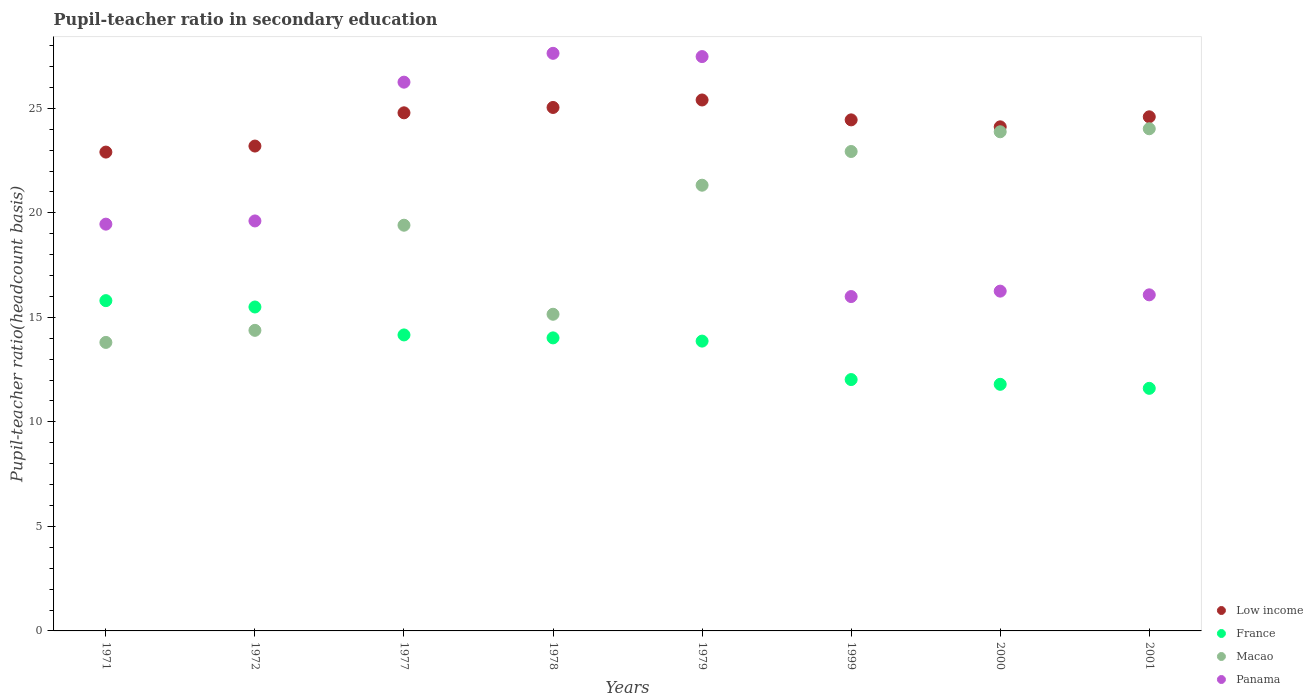How many different coloured dotlines are there?
Offer a terse response. 4. What is the pupil-teacher ratio in secondary education in France in 2001?
Your answer should be very brief. 11.61. Across all years, what is the maximum pupil-teacher ratio in secondary education in Macao?
Offer a terse response. 24.02. Across all years, what is the minimum pupil-teacher ratio in secondary education in Panama?
Your answer should be compact. 16. In which year was the pupil-teacher ratio in secondary education in Low income maximum?
Provide a succinct answer. 1979. What is the total pupil-teacher ratio in secondary education in Macao in the graph?
Keep it short and to the point. 154.91. What is the difference between the pupil-teacher ratio in secondary education in France in 1978 and that in 1999?
Give a very brief answer. 1.99. What is the difference between the pupil-teacher ratio in secondary education in Panama in 2001 and the pupil-teacher ratio in secondary education in Low income in 2000?
Your answer should be very brief. -8.04. What is the average pupil-teacher ratio in secondary education in Panama per year?
Your answer should be very brief. 21.1. In the year 1979, what is the difference between the pupil-teacher ratio in secondary education in Panama and pupil-teacher ratio in secondary education in France?
Your answer should be very brief. 13.61. What is the ratio of the pupil-teacher ratio in secondary education in France in 1979 to that in 2000?
Your answer should be very brief. 1.18. What is the difference between the highest and the second highest pupil-teacher ratio in secondary education in Macao?
Your answer should be very brief. 0.14. What is the difference between the highest and the lowest pupil-teacher ratio in secondary education in Panama?
Provide a succinct answer. 11.64. In how many years, is the pupil-teacher ratio in secondary education in France greater than the average pupil-teacher ratio in secondary education in France taken over all years?
Provide a succinct answer. 5. Is the sum of the pupil-teacher ratio in secondary education in Panama in 1999 and 2000 greater than the maximum pupil-teacher ratio in secondary education in France across all years?
Your response must be concise. Yes. Is the pupil-teacher ratio in secondary education in Macao strictly greater than the pupil-teacher ratio in secondary education in France over the years?
Your response must be concise. No. How many dotlines are there?
Your response must be concise. 4. How many years are there in the graph?
Offer a very short reply. 8. Does the graph contain any zero values?
Give a very brief answer. No. Where does the legend appear in the graph?
Provide a short and direct response. Bottom right. What is the title of the graph?
Your response must be concise. Pupil-teacher ratio in secondary education. Does "Turkey" appear as one of the legend labels in the graph?
Offer a terse response. No. What is the label or title of the X-axis?
Offer a terse response. Years. What is the label or title of the Y-axis?
Ensure brevity in your answer.  Pupil-teacher ratio(headcount basis). What is the Pupil-teacher ratio(headcount basis) of Low income in 1971?
Your answer should be very brief. 22.91. What is the Pupil-teacher ratio(headcount basis) in France in 1971?
Offer a terse response. 15.8. What is the Pupil-teacher ratio(headcount basis) in Macao in 1971?
Your response must be concise. 13.8. What is the Pupil-teacher ratio(headcount basis) of Panama in 1971?
Ensure brevity in your answer.  19.46. What is the Pupil-teacher ratio(headcount basis) of Low income in 1972?
Your answer should be compact. 23.2. What is the Pupil-teacher ratio(headcount basis) in France in 1972?
Make the answer very short. 15.5. What is the Pupil-teacher ratio(headcount basis) of Macao in 1972?
Your response must be concise. 14.38. What is the Pupil-teacher ratio(headcount basis) of Panama in 1972?
Offer a terse response. 19.61. What is the Pupil-teacher ratio(headcount basis) in Low income in 1977?
Your response must be concise. 24.79. What is the Pupil-teacher ratio(headcount basis) of France in 1977?
Your answer should be compact. 14.16. What is the Pupil-teacher ratio(headcount basis) in Macao in 1977?
Your response must be concise. 19.41. What is the Pupil-teacher ratio(headcount basis) of Panama in 1977?
Ensure brevity in your answer.  26.25. What is the Pupil-teacher ratio(headcount basis) of Low income in 1978?
Offer a terse response. 25.04. What is the Pupil-teacher ratio(headcount basis) in France in 1978?
Your response must be concise. 14.02. What is the Pupil-teacher ratio(headcount basis) in Macao in 1978?
Keep it short and to the point. 15.15. What is the Pupil-teacher ratio(headcount basis) of Panama in 1978?
Offer a terse response. 27.63. What is the Pupil-teacher ratio(headcount basis) in Low income in 1979?
Your answer should be compact. 25.4. What is the Pupil-teacher ratio(headcount basis) of France in 1979?
Provide a succinct answer. 13.87. What is the Pupil-teacher ratio(headcount basis) of Macao in 1979?
Your answer should be very brief. 21.32. What is the Pupil-teacher ratio(headcount basis) of Panama in 1979?
Ensure brevity in your answer.  27.48. What is the Pupil-teacher ratio(headcount basis) of Low income in 1999?
Your response must be concise. 24.45. What is the Pupil-teacher ratio(headcount basis) of France in 1999?
Make the answer very short. 12.03. What is the Pupil-teacher ratio(headcount basis) of Macao in 1999?
Offer a very short reply. 22.94. What is the Pupil-teacher ratio(headcount basis) in Panama in 1999?
Your response must be concise. 16. What is the Pupil-teacher ratio(headcount basis) of Low income in 2000?
Your response must be concise. 24.12. What is the Pupil-teacher ratio(headcount basis) of France in 2000?
Your answer should be compact. 11.8. What is the Pupil-teacher ratio(headcount basis) in Macao in 2000?
Make the answer very short. 23.88. What is the Pupil-teacher ratio(headcount basis) in Panama in 2000?
Provide a short and direct response. 16.26. What is the Pupil-teacher ratio(headcount basis) in Low income in 2001?
Ensure brevity in your answer.  24.6. What is the Pupil-teacher ratio(headcount basis) of France in 2001?
Offer a very short reply. 11.61. What is the Pupil-teacher ratio(headcount basis) of Macao in 2001?
Provide a succinct answer. 24.02. What is the Pupil-teacher ratio(headcount basis) of Panama in 2001?
Give a very brief answer. 16.08. Across all years, what is the maximum Pupil-teacher ratio(headcount basis) in Low income?
Offer a very short reply. 25.4. Across all years, what is the maximum Pupil-teacher ratio(headcount basis) of France?
Offer a very short reply. 15.8. Across all years, what is the maximum Pupil-teacher ratio(headcount basis) of Macao?
Keep it short and to the point. 24.02. Across all years, what is the maximum Pupil-teacher ratio(headcount basis) of Panama?
Provide a succinct answer. 27.63. Across all years, what is the minimum Pupil-teacher ratio(headcount basis) of Low income?
Give a very brief answer. 22.91. Across all years, what is the minimum Pupil-teacher ratio(headcount basis) of France?
Give a very brief answer. 11.61. Across all years, what is the minimum Pupil-teacher ratio(headcount basis) of Macao?
Make the answer very short. 13.8. Across all years, what is the minimum Pupil-teacher ratio(headcount basis) of Panama?
Provide a short and direct response. 16. What is the total Pupil-teacher ratio(headcount basis) of Low income in the graph?
Give a very brief answer. 194.5. What is the total Pupil-teacher ratio(headcount basis) of France in the graph?
Give a very brief answer. 108.77. What is the total Pupil-teacher ratio(headcount basis) in Macao in the graph?
Provide a succinct answer. 154.91. What is the total Pupil-teacher ratio(headcount basis) in Panama in the graph?
Provide a short and direct response. 168.77. What is the difference between the Pupil-teacher ratio(headcount basis) in Low income in 1971 and that in 1972?
Offer a very short reply. -0.29. What is the difference between the Pupil-teacher ratio(headcount basis) in France in 1971 and that in 1972?
Make the answer very short. 0.3. What is the difference between the Pupil-teacher ratio(headcount basis) in Macao in 1971 and that in 1972?
Give a very brief answer. -0.58. What is the difference between the Pupil-teacher ratio(headcount basis) of Panama in 1971 and that in 1972?
Give a very brief answer. -0.15. What is the difference between the Pupil-teacher ratio(headcount basis) in Low income in 1971 and that in 1977?
Give a very brief answer. -1.88. What is the difference between the Pupil-teacher ratio(headcount basis) of France in 1971 and that in 1977?
Provide a succinct answer. 1.64. What is the difference between the Pupil-teacher ratio(headcount basis) of Macao in 1971 and that in 1977?
Offer a terse response. -5.61. What is the difference between the Pupil-teacher ratio(headcount basis) of Panama in 1971 and that in 1977?
Keep it short and to the point. -6.79. What is the difference between the Pupil-teacher ratio(headcount basis) in Low income in 1971 and that in 1978?
Your answer should be compact. -2.13. What is the difference between the Pupil-teacher ratio(headcount basis) of France in 1971 and that in 1978?
Your answer should be very brief. 1.78. What is the difference between the Pupil-teacher ratio(headcount basis) in Macao in 1971 and that in 1978?
Give a very brief answer. -1.35. What is the difference between the Pupil-teacher ratio(headcount basis) of Panama in 1971 and that in 1978?
Ensure brevity in your answer.  -8.17. What is the difference between the Pupil-teacher ratio(headcount basis) in Low income in 1971 and that in 1979?
Your response must be concise. -2.49. What is the difference between the Pupil-teacher ratio(headcount basis) in France in 1971 and that in 1979?
Keep it short and to the point. 1.94. What is the difference between the Pupil-teacher ratio(headcount basis) in Macao in 1971 and that in 1979?
Your answer should be very brief. -7.52. What is the difference between the Pupil-teacher ratio(headcount basis) in Panama in 1971 and that in 1979?
Offer a terse response. -8.02. What is the difference between the Pupil-teacher ratio(headcount basis) in Low income in 1971 and that in 1999?
Offer a terse response. -1.54. What is the difference between the Pupil-teacher ratio(headcount basis) in France in 1971 and that in 1999?
Give a very brief answer. 3.78. What is the difference between the Pupil-teacher ratio(headcount basis) of Macao in 1971 and that in 1999?
Your answer should be compact. -9.13. What is the difference between the Pupil-teacher ratio(headcount basis) of Panama in 1971 and that in 1999?
Ensure brevity in your answer.  3.46. What is the difference between the Pupil-teacher ratio(headcount basis) of Low income in 1971 and that in 2000?
Your answer should be very brief. -1.21. What is the difference between the Pupil-teacher ratio(headcount basis) in France in 1971 and that in 2000?
Your response must be concise. 4. What is the difference between the Pupil-teacher ratio(headcount basis) of Macao in 1971 and that in 2000?
Ensure brevity in your answer.  -10.08. What is the difference between the Pupil-teacher ratio(headcount basis) of Panama in 1971 and that in 2000?
Ensure brevity in your answer.  3.2. What is the difference between the Pupil-teacher ratio(headcount basis) of Low income in 1971 and that in 2001?
Provide a short and direct response. -1.69. What is the difference between the Pupil-teacher ratio(headcount basis) of France in 1971 and that in 2001?
Offer a very short reply. 4.2. What is the difference between the Pupil-teacher ratio(headcount basis) in Macao in 1971 and that in 2001?
Make the answer very short. -10.22. What is the difference between the Pupil-teacher ratio(headcount basis) of Panama in 1971 and that in 2001?
Offer a terse response. 3.38. What is the difference between the Pupil-teacher ratio(headcount basis) of Low income in 1972 and that in 1977?
Give a very brief answer. -1.59. What is the difference between the Pupil-teacher ratio(headcount basis) of France in 1972 and that in 1977?
Offer a very short reply. 1.34. What is the difference between the Pupil-teacher ratio(headcount basis) of Macao in 1972 and that in 1977?
Make the answer very short. -5.03. What is the difference between the Pupil-teacher ratio(headcount basis) in Panama in 1972 and that in 1977?
Offer a terse response. -6.64. What is the difference between the Pupil-teacher ratio(headcount basis) of Low income in 1972 and that in 1978?
Give a very brief answer. -1.85. What is the difference between the Pupil-teacher ratio(headcount basis) in France in 1972 and that in 1978?
Make the answer very short. 1.48. What is the difference between the Pupil-teacher ratio(headcount basis) in Macao in 1972 and that in 1978?
Offer a terse response. -0.77. What is the difference between the Pupil-teacher ratio(headcount basis) of Panama in 1972 and that in 1978?
Offer a terse response. -8.02. What is the difference between the Pupil-teacher ratio(headcount basis) in Low income in 1972 and that in 1979?
Make the answer very short. -2.2. What is the difference between the Pupil-teacher ratio(headcount basis) in France in 1972 and that in 1979?
Make the answer very short. 1.63. What is the difference between the Pupil-teacher ratio(headcount basis) of Macao in 1972 and that in 1979?
Make the answer very short. -6.94. What is the difference between the Pupil-teacher ratio(headcount basis) of Panama in 1972 and that in 1979?
Your response must be concise. -7.86. What is the difference between the Pupil-teacher ratio(headcount basis) of Low income in 1972 and that in 1999?
Provide a short and direct response. -1.25. What is the difference between the Pupil-teacher ratio(headcount basis) of France in 1972 and that in 1999?
Make the answer very short. 3.47. What is the difference between the Pupil-teacher ratio(headcount basis) of Macao in 1972 and that in 1999?
Provide a succinct answer. -8.56. What is the difference between the Pupil-teacher ratio(headcount basis) in Panama in 1972 and that in 1999?
Offer a very short reply. 3.62. What is the difference between the Pupil-teacher ratio(headcount basis) in Low income in 1972 and that in 2000?
Offer a very short reply. -0.92. What is the difference between the Pupil-teacher ratio(headcount basis) of France in 1972 and that in 2000?
Ensure brevity in your answer.  3.7. What is the difference between the Pupil-teacher ratio(headcount basis) in Macao in 1972 and that in 2000?
Make the answer very short. -9.5. What is the difference between the Pupil-teacher ratio(headcount basis) in Panama in 1972 and that in 2000?
Keep it short and to the point. 3.36. What is the difference between the Pupil-teacher ratio(headcount basis) of Low income in 1972 and that in 2001?
Keep it short and to the point. -1.4. What is the difference between the Pupil-teacher ratio(headcount basis) of France in 1972 and that in 2001?
Provide a short and direct response. 3.89. What is the difference between the Pupil-teacher ratio(headcount basis) of Macao in 1972 and that in 2001?
Offer a terse response. -9.64. What is the difference between the Pupil-teacher ratio(headcount basis) in Panama in 1972 and that in 2001?
Your answer should be compact. 3.54. What is the difference between the Pupil-teacher ratio(headcount basis) of Low income in 1977 and that in 1978?
Ensure brevity in your answer.  -0.26. What is the difference between the Pupil-teacher ratio(headcount basis) in France in 1977 and that in 1978?
Your response must be concise. 0.14. What is the difference between the Pupil-teacher ratio(headcount basis) of Macao in 1977 and that in 1978?
Offer a terse response. 4.26. What is the difference between the Pupil-teacher ratio(headcount basis) in Panama in 1977 and that in 1978?
Give a very brief answer. -1.38. What is the difference between the Pupil-teacher ratio(headcount basis) in Low income in 1977 and that in 1979?
Ensure brevity in your answer.  -0.61. What is the difference between the Pupil-teacher ratio(headcount basis) of France in 1977 and that in 1979?
Your response must be concise. 0.3. What is the difference between the Pupil-teacher ratio(headcount basis) in Macao in 1977 and that in 1979?
Your answer should be compact. -1.91. What is the difference between the Pupil-teacher ratio(headcount basis) in Panama in 1977 and that in 1979?
Your answer should be very brief. -1.22. What is the difference between the Pupil-teacher ratio(headcount basis) of Low income in 1977 and that in 1999?
Keep it short and to the point. 0.34. What is the difference between the Pupil-teacher ratio(headcount basis) of France in 1977 and that in 1999?
Keep it short and to the point. 2.14. What is the difference between the Pupil-teacher ratio(headcount basis) of Macao in 1977 and that in 1999?
Your response must be concise. -3.53. What is the difference between the Pupil-teacher ratio(headcount basis) in Panama in 1977 and that in 1999?
Give a very brief answer. 10.26. What is the difference between the Pupil-teacher ratio(headcount basis) of Low income in 1977 and that in 2000?
Give a very brief answer. 0.67. What is the difference between the Pupil-teacher ratio(headcount basis) in France in 1977 and that in 2000?
Offer a terse response. 2.36. What is the difference between the Pupil-teacher ratio(headcount basis) of Macao in 1977 and that in 2000?
Give a very brief answer. -4.47. What is the difference between the Pupil-teacher ratio(headcount basis) of Panama in 1977 and that in 2000?
Offer a very short reply. 10. What is the difference between the Pupil-teacher ratio(headcount basis) of Low income in 1977 and that in 2001?
Provide a short and direct response. 0.19. What is the difference between the Pupil-teacher ratio(headcount basis) of France in 1977 and that in 2001?
Offer a very short reply. 2.56. What is the difference between the Pupil-teacher ratio(headcount basis) of Macao in 1977 and that in 2001?
Offer a terse response. -4.61. What is the difference between the Pupil-teacher ratio(headcount basis) of Panama in 1977 and that in 2001?
Make the answer very short. 10.17. What is the difference between the Pupil-teacher ratio(headcount basis) in Low income in 1978 and that in 1979?
Your answer should be very brief. -0.36. What is the difference between the Pupil-teacher ratio(headcount basis) in France in 1978 and that in 1979?
Offer a very short reply. 0.15. What is the difference between the Pupil-teacher ratio(headcount basis) in Macao in 1978 and that in 1979?
Provide a short and direct response. -6.17. What is the difference between the Pupil-teacher ratio(headcount basis) of Panama in 1978 and that in 1979?
Your response must be concise. 0.16. What is the difference between the Pupil-teacher ratio(headcount basis) of Low income in 1978 and that in 1999?
Provide a short and direct response. 0.59. What is the difference between the Pupil-teacher ratio(headcount basis) of France in 1978 and that in 1999?
Your answer should be very brief. 1.99. What is the difference between the Pupil-teacher ratio(headcount basis) in Macao in 1978 and that in 1999?
Ensure brevity in your answer.  -7.79. What is the difference between the Pupil-teacher ratio(headcount basis) in Panama in 1978 and that in 1999?
Ensure brevity in your answer.  11.64. What is the difference between the Pupil-teacher ratio(headcount basis) in Low income in 1978 and that in 2000?
Make the answer very short. 0.93. What is the difference between the Pupil-teacher ratio(headcount basis) of France in 1978 and that in 2000?
Offer a terse response. 2.22. What is the difference between the Pupil-teacher ratio(headcount basis) in Macao in 1978 and that in 2000?
Ensure brevity in your answer.  -8.73. What is the difference between the Pupil-teacher ratio(headcount basis) of Panama in 1978 and that in 2000?
Give a very brief answer. 11.38. What is the difference between the Pupil-teacher ratio(headcount basis) of Low income in 1978 and that in 2001?
Offer a terse response. 0.45. What is the difference between the Pupil-teacher ratio(headcount basis) of France in 1978 and that in 2001?
Offer a terse response. 2.41. What is the difference between the Pupil-teacher ratio(headcount basis) in Macao in 1978 and that in 2001?
Your answer should be compact. -8.87. What is the difference between the Pupil-teacher ratio(headcount basis) of Panama in 1978 and that in 2001?
Give a very brief answer. 11.55. What is the difference between the Pupil-teacher ratio(headcount basis) of Low income in 1979 and that in 1999?
Make the answer very short. 0.95. What is the difference between the Pupil-teacher ratio(headcount basis) of France in 1979 and that in 1999?
Offer a terse response. 1.84. What is the difference between the Pupil-teacher ratio(headcount basis) of Macao in 1979 and that in 1999?
Your response must be concise. -1.61. What is the difference between the Pupil-teacher ratio(headcount basis) in Panama in 1979 and that in 1999?
Your answer should be very brief. 11.48. What is the difference between the Pupil-teacher ratio(headcount basis) of Low income in 1979 and that in 2000?
Keep it short and to the point. 1.28. What is the difference between the Pupil-teacher ratio(headcount basis) in France in 1979 and that in 2000?
Offer a very short reply. 2.07. What is the difference between the Pupil-teacher ratio(headcount basis) of Macao in 1979 and that in 2000?
Provide a short and direct response. -2.56. What is the difference between the Pupil-teacher ratio(headcount basis) of Panama in 1979 and that in 2000?
Your response must be concise. 11.22. What is the difference between the Pupil-teacher ratio(headcount basis) of Low income in 1979 and that in 2001?
Offer a very short reply. 0.81. What is the difference between the Pupil-teacher ratio(headcount basis) of France in 1979 and that in 2001?
Provide a succinct answer. 2.26. What is the difference between the Pupil-teacher ratio(headcount basis) of Panama in 1979 and that in 2001?
Ensure brevity in your answer.  11.4. What is the difference between the Pupil-teacher ratio(headcount basis) of Low income in 1999 and that in 2000?
Give a very brief answer. 0.33. What is the difference between the Pupil-teacher ratio(headcount basis) in France in 1999 and that in 2000?
Your answer should be very brief. 0.23. What is the difference between the Pupil-teacher ratio(headcount basis) in Macao in 1999 and that in 2000?
Your response must be concise. -0.94. What is the difference between the Pupil-teacher ratio(headcount basis) in Panama in 1999 and that in 2000?
Offer a very short reply. -0.26. What is the difference between the Pupil-teacher ratio(headcount basis) of Low income in 1999 and that in 2001?
Offer a very short reply. -0.15. What is the difference between the Pupil-teacher ratio(headcount basis) of France in 1999 and that in 2001?
Offer a terse response. 0.42. What is the difference between the Pupil-teacher ratio(headcount basis) in Macao in 1999 and that in 2001?
Your answer should be compact. -1.09. What is the difference between the Pupil-teacher ratio(headcount basis) of Panama in 1999 and that in 2001?
Give a very brief answer. -0.08. What is the difference between the Pupil-teacher ratio(headcount basis) of Low income in 2000 and that in 2001?
Offer a very short reply. -0.48. What is the difference between the Pupil-teacher ratio(headcount basis) in France in 2000 and that in 2001?
Offer a very short reply. 0.19. What is the difference between the Pupil-teacher ratio(headcount basis) of Macao in 2000 and that in 2001?
Your answer should be compact. -0.14. What is the difference between the Pupil-teacher ratio(headcount basis) in Panama in 2000 and that in 2001?
Your answer should be very brief. 0.18. What is the difference between the Pupil-teacher ratio(headcount basis) of Low income in 1971 and the Pupil-teacher ratio(headcount basis) of France in 1972?
Ensure brevity in your answer.  7.41. What is the difference between the Pupil-teacher ratio(headcount basis) in Low income in 1971 and the Pupil-teacher ratio(headcount basis) in Macao in 1972?
Your response must be concise. 8.53. What is the difference between the Pupil-teacher ratio(headcount basis) in Low income in 1971 and the Pupil-teacher ratio(headcount basis) in Panama in 1972?
Ensure brevity in your answer.  3.29. What is the difference between the Pupil-teacher ratio(headcount basis) of France in 1971 and the Pupil-teacher ratio(headcount basis) of Macao in 1972?
Make the answer very short. 1.42. What is the difference between the Pupil-teacher ratio(headcount basis) of France in 1971 and the Pupil-teacher ratio(headcount basis) of Panama in 1972?
Offer a terse response. -3.81. What is the difference between the Pupil-teacher ratio(headcount basis) in Macao in 1971 and the Pupil-teacher ratio(headcount basis) in Panama in 1972?
Give a very brief answer. -5.81. What is the difference between the Pupil-teacher ratio(headcount basis) in Low income in 1971 and the Pupil-teacher ratio(headcount basis) in France in 1977?
Offer a very short reply. 8.75. What is the difference between the Pupil-teacher ratio(headcount basis) of Low income in 1971 and the Pupil-teacher ratio(headcount basis) of Macao in 1977?
Keep it short and to the point. 3.5. What is the difference between the Pupil-teacher ratio(headcount basis) in Low income in 1971 and the Pupil-teacher ratio(headcount basis) in Panama in 1977?
Give a very brief answer. -3.35. What is the difference between the Pupil-teacher ratio(headcount basis) in France in 1971 and the Pupil-teacher ratio(headcount basis) in Macao in 1977?
Give a very brief answer. -3.61. What is the difference between the Pupil-teacher ratio(headcount basis) in France in 1971 and the Pupil-teacher ratio(headcount basis) in Panama in 1977?
Keep it short and to the point. -10.45. What is the difference between the Pupil-teacher ratio(headcount basis) of Macao in 1971 and the Pupil-teacher ratio(headcount basis) of Panama in 1977?
Give a very brief answer. -12.45. What is the difference between the Pupil-teacher ratio(headcount basis) in Low income in 1971 and the Pupil-teacher ratio(headcount basis) in France in 1978?
Ensure brevity in your answer.  8.89. What is the difference between the Pupil-teacher ratio(headcount basis) in Low income in 1971 and the Pupil-teacher ratio(headcount basis) in Macao in 1978?
Keep it short and to the point. 7.76. What is the difference between the Pupil-teacher ratio(headcount basis) of Low income in 1971 and the Pupil-teacher ratio(headcount basis) of Panama in 1978?
Ensure brevity in your answer.  -4.72. What is the difference between the Pupil-teacher ratio(headcount basis) in France in 1971 and the Pupil-teacher ratio(headcount basis) in Macao in 1978?
Offer a very short reply. 0.65. What is the difference between the Pupil-teacher ratio(headcount basis) of France in 1971 and the Pupil-teacher ratio(headcount basis) of Panama in 1978?
Make the answer very short. -11.83. What is the difference between the Pupil-teacher ratio(headcount basis) in Macao in 1971 and the Pupil-teacher ratio(headcount basis) in Panama in 1978?
Your answer should be compact. -13.83. What is the difference between the Pupil-teacher ratio(headcount basis) of Low income in 1971 and the Pupil-teacher ratio(headcount basis) of France in 1979?
Offer a terse response. 9.04. What is the difference between the Pupil-teacher ratio(headcount basis) in Low income in 1971 and the Pupil-teacher ratio(headcount basis) in Macao in 1979?
Provide a short and direct response. 1.58. What is the difference between the Pupil-teacher ratio(headcount basis) of Low income in 1971 and the Pupil-teacher ratio(headcount basis) of Panama in 1979?
Your response must be concise. -4.57. What is the difference between the Pupil-teacher ratio(headcount basis) in France in 1971 and the Pupil-teacher ratio(headcount basis) in Macao in 1979?
Your answer should be compact. -5.52. What is the difference between the Pupil-teacher ratio(headcount basis) in France in 1971 and the Pupil-teacher ratio(headcount basis) in Panama in 1979?
Keep it short and to the point. -11.68. What is the difference between the Pupil-teacher ratio(headcount basis) of Macao in 1971 and the Pupil-teacher ratio(headcount basis) of Panama in 1979?
Offer a very short reply. -13.68. What is the difference between the Pupil-teacher ratio(headcount basis) of Low income in 1971 and the Pupil-teacher ratio(headcount basis) of France in 1999?
Your response must be concise. 10.88. What is the difference between the Pupil-teacher ratio(headcount basis) of Low income in 1971 and the Pupil-teacher ratio(headcount basis) of Macao in 1999?
Provide a succinct answer. -0.03. What is the difference between the Pupil-teacher ratio(headcount basis) in Low income in 1971 and the Pupil-teacher ratio(headcount basis) in Panama in 1999?
Make the answer very short. 6.91. What is the difference between the Pupil-teacher ratio(headcount basis) of France in 1971 and the Pupil-teacher ratio(headcount basis) of Macao in 1999?
Your answer should be compact. -7.13. What is the difference between the Pupil-teacher ratio(headcount basis) of France in 1971 and the Pupil-teacher ratio(headcount basis) of Panama in 1999?
Your response must be concise. -0.2. What is the difference between the Pupil-teacher ratio(headcount basis) of Macao in 1971 and the Pupil-teacher ratio(headcount basis) of Panama in 1999?
Your answer should be very brief. -2.19. What is the difference between the Pupil-teacher ratio(headcount basis) in Low income in 1971 and the Pupil-teacher ratio(headcount basis) in France in 2000?
Provide a succinct answer. 11.11. What is the difference between the Pupil-teacher ratio(headcount basis) in Low income in 1971 and the Pupil-teacher ratio(headcount basis) in Macao in 2000?
Provide a short and direct response. -0.97. What is the difference between the Pupil-teacher ratio(headcount basis) of Low income in 1971 and the Pupil-teacher ratio(headcount basis) of Panama in 2000?
Offer a terse response. 6.65. What is the difference between the Pupil-teacher ratio(headcount basis) in France in 1971 and the Pupil-teacher ratio(headcount basis) in Macao in 2000?
Keep it short and to the point. -8.08. What is the difference between the Pupil-teacher ratio(headcount basis) in France in 1971 and the Pupil-teacher ratio(headcount basis) in Panama in 2000?
Make the answer very short. -0.45. What is the difference between the Pupil-teacher ratio(headcount basis) in Macao in 1971 and the Pupil-teacher ratio(headcount basis) in Panama in 2000?
Your response must be concise. -2.45. What is the difference between the Pupil-teacher ratio(headcount basis) of Low income in 1971 and the Pupil-teacher ratio(headcount basis) of France in 2001?
Give a very brief answer. 11.3. What is the difference between the Pupil-teacher ratio(headcount basis) of Low income in 1971 and the Pupil-teacher ratio(headcount basis) of Macao in 2001?
Ensure brevity in your answer.  -1.12. What is the difference between the Pupil-teacher ratio(headcount basis) of Low income in 1971 and the Pupil-teacher ratio(headcount basis) of Panama in 2001?
Your answer should be very brief. 6.83. What is the difference between the Pupil-teacher ratio(headcount basis) of France in 1971 and the Pupil-teacher ratio(headcount basis) of Macao in 2001?
Your answer should be very brief. -8.22. What is the difference between the Pupil-teacher ratio(headcount basis) of France in 1971 and the Pupil-teacher ratio(headcount basis) of Panama in 2001?
Your answer should be compact. -0.28. What is the difference between the Pupil-teacher ratio(headcount basis) of Macao in 1971 and the Pupil-teacher ratio(headcount basis) of Panama in 2001?
Offer a very short reply. -2.28. What is the difference between the Pupil-teacher ratio(headcount basis) in Low income in 1972 and the Pupil-teacher ratio(headcount basis) in France in 1977?
Keep it short and to the point. 9.04. What is the difference between the Pupil-teacher ratio(headcount basis) of Low income in 1972 and the Pupil-teacher ratio(headcount basis) of Macao in 1977?
Keep it short and to the point. 3.79. What is the difference between the Pupil-teacher ratio(headcount basis) of Low income in 1972 and the Pupil-teacher ratio(headcount basis) of Panama in 1977?
Keep it short and to the point. -3.06. What is the difference between the Pupil-teacher ratio(headcount basis) of France in 1972 and the Pupil-teacher ratio(headcount basis) of Macao in 1977?
Provide a short and direct response. -3.91. What is the difference between the Pupil-teacher ratio(headcount basis) of France in 1972 and the Pupil-teacher ratio(headcount basis) of Panama in 1977?
Your response must be concise. -10.76. What is the difference between the Pupil-teacher ratio(headcount basis) of Macao in 1972 and the Pupil-teacher ratio(headcount basis) of Panama in 1977?
Keep it short and to the point. -11.87. What is the difference between the Pupil-teacher ratio(headcount basis) of Low income in 1972 and the Pupil-teacher ratio(headcount basis) of France in 1978?
Provide a short and direct response. 9.18. What is the difference between the Pupil-teacher ratio(headcount basis) in Low income in 1972 and the Pupil-teacher ratio(headcount basis) in Macao in 1978?
Ensure brevity in your answer.  8.05. What is the difference between the Pupil-teacher ratio(headcount basis) in Low income in 1972 and the Pupil-teacher ratio(headcount basis) in Panama in 1978?
Offer a terse response. -4.44. What is the difference between the Pupil-teacher ratio(headcount basis) in France in 1972 and the Pupil-teacher ratio(headcount basis) in Macao in 1978?
Provide a succinct answer. 0.35. What is the difference between the Pupil-teacher ratio(headcount basis) in France in 1972 and the Pupil-teacher ratio(headcount basis) in Panama in 1978?
Give a very brief answer. -12.14. What is the difference between the Pupil-teacher ratio(headcount basis) in Macao in 1972 and the Pupil-teacher ratio(headcount basis) in Panama in 1978?
Offer a terse response. -13.25. What is the difference between the Pupil-teacher ratio(headcount basis) of Low income in 1972 and the Pupil-teacher ratio(headcount basis) of France in 1979?
Give a very brief answer. 9.33. What is the difference between the Pupil-teacher ratio(headcount basis) of Low income in 1972 and the Pupil-teacher ratio(headcount basis) of Macao in 1979?
Provide a short and direct response. 1.87. What is the difference between the Pupil-teacher ratio(headcount basis) of Low income in 1972 and the Pupil-teacher ratio(headcount basis) of Panama in 1979?
Make the answer very short. -4.28. What is the difference between the Pupil-teacher ratio(headcount basis) of France in 1972 and the Pupil-teacher ratio(headcount basis) of Macao in 1979?
Ensure brevity in your answer.  -5.83. What is the difference between the Pupil-teacher ratio(headcount basis) of France in 1972 and the Pupil-teacher ratio(headcount basis) of Panama in 1979?
Offer a very short reply. -11.98. What is the difference between the Pupil-teacher ratio(headcount basis) of Macao in 1972 and the Pupil-teacher ratio(headcount basis) of Panama in 1979?
Keep it short and to the point. -13.1. What is the difference between the Pupil-teacher ratio(headcount basis) of Low income in 1972 and the Pupil-teacher ratio(headcount basis) of France in 1999?
Offer a very short reply. 11.17. What is the difference between the Pupil-teacher ratio(headcount basis) of Low income in 1972 and the Pupil-teacher ratio(headcount basis) of Macao in 1999?
Your answer should be compact. 0.26. What is the difference between the Pupil-teacher ratio(headcount basis) of Low income in 1972 and the Pupil-teacher ratio(headcount basis) of Panama in 1999?
Keep it short and to the point. 7.2. What is the difference between the Pupil-teacher ratio(headcount basis) of France in 1972 and the Pupil-teacher ratio(headcount basis) of Macao in 1999?
Provide a succinct answer. -7.44. What is the difference between the Pupil-teacher ratio(headcount basis) in France in 1972 and the Pupil-teacher ratio(headcount basis) in Panama in 1999?
Your answer should be compact. -0.5. What is the difference between the Pupil-teacher ratio(headcount basis) of Macao in 1972 and the Pupil-teacher ratio(headcount basis) of Panama in 1999?
Your answer should be very brief. -1.62. What is the difference between the Pupil-teacher ratio(headcount basis) of Low income in 1972 and the Pupil-teacher ratio(headcount basis) of France in 2000?
Provide a succinct answer. 11.4. What is the difference between the Pupil-teacher ratio(headcount basis) of Low income in 1972 and the Pupil-teacher ratio(headcount basis) of Macao in 2000?
Your answer should be very brief. -0.68. What is the difference between the Pupil-teacher ratio(headcount basis) in Low income in 1972 and the Pupil-teacher ratio(headcount basis) in Panama in 2000?
Offer a terse response. 6.94. What is the difference between the Pupil-teacher ratio(headcount basis) in France in 1972 and the Pupil-teacher ratio(headcount basis) in Macao in 2000?
Offer a very short reply. -8.38. What is the difference between the Pupil-teacher ratio(headcount basis) in France in 1972 and the Pupil-teacher ratio(headcount basis) in Panama in 2000?
Provide a succinct answer. -0.76. What is the difference between the Pupil-teacher ratio(headcount basis) in Macao in 1972 and the Pupil-teacher ratio(headcount basis) in Panama in 2000?
Give a very brief answer. -1.88. What is the difference between the Pupil-teacher ratio(headcount basis) of Low income in 1972 and the Pupil-teacher ratio(headcount basis) of France in 2001?
Provide a succinct answer. 11.59. What is the difference between the Pupil-teacher ratio(headcount basis) in Low income in 1972 and the Pupil-teacher ratio(headcount basis) in Macao in 2001?
Give a very brief answer. -0.83. What is the difference between the Pupil-teacher ratio(headcount basis) in Low income in 1972 and the Pupil-teacher ratio(headcount basis) in Panama in 2001?
Provide a succinct answer. 7.12. What is the difference between the Pupil-teacher ratio(headcount basis) in France in 1972 and the Pupil-teacher ratio(headcount basis) in Macao in 2001?
Offer a very short reply. -8.53. What is the difference between the Pupil-teacher ratio(headcount basis) in France in 1972 and the Pupil-teacher ratio(headcount basis) in Panama in 2001?
Provide a short and direct response. -0.58. What is the difference between the Pupil-teacher ratio(headcount basis) of Macao in 1972 and the Pupil-teacher ratio(headcount basis) of Panama in 2001?
Ensure brevity in your answer.  -1.7. What is the difference between the Pupil-teacher ratio(headcount basis) in Low income in 1977 and the Pupil-teacher ratio(headcount basis) in France in 1978?
Make the answer very short. 10.77. What is the difference between the Pupil-teacher ratio(headcount basis) of Low income in 1977 and the Pupil-teacher ratio(headcount basis) of Macao in 1978?
Provide a short and direct response. 9.64. What is the difference between the Pupil-teacher ratio(headcount basis) of Low income in 1977 and the Pupil-teacher ratio(headcount basis) of Panama in 1978?
Give a very brief answer. -2.85. What is the difference between the Pupil-teacher ratio(headcount basis) in France in 1977 and the Pupil-teacher ratio(headcount basis) in Macao in 1978?
Make the answer very short. -0.99. What is the difference between the Pupil-teacher ratio(headcount basis) of France in 1977 and the Pupil-teacher ratio(headcount basis) of Panama in 1978?
Your answer should be compact. -13.47. What is the difference between the Pupil-teacher ratio(headcount basis) in Macao in 1977 and the Pupil-teacher ratio(headcount basis) in Panama in 1978?
Provide a short and direct response. -8.22. What is the difference between the Pupil-teacher ratio(headcount basis) in Low income in 1977 and the Pupil-teacher ratio(headcount basis) in France in 1979?
Make the answer very short. 10.92. What is the difference between the Pupil-teacher ratio(headcount basis) of Low income in 1977 and the Pupil-teacher ratio(headcount basis) of Macao in 1979?
Offer a very short reply. 3.46. What is the difference between the Pupil-teacher ratio(headcount basis) of Low income in 1977 and the Pupil-teacher ratio(headcount basis) of Panama in 1979?
Your answer should be very brief. -2.69. What is the difference between the Pupil-teacher ratio(headcount basis) of France in 1977 and the Pupil-teacher ratio(headcount basis) of Macao in 1979?
Offer a terse response. -7.16. What is the difference between the Pupil-teacher ratio(headcount basis) in France in 1977 and the Pupil-teacher ratio(headcount basis) in Panama in 1979?
Keep it short and to the point. -13.32. What is the difference between the Pupil-teacher ratio(headcount basis) of Macao in 1977 and the Pupil-teacher ratio(headcount basis) of Panama in 1979?
Provide a succinct answer. -8.07. What is the difference between the Pupil-teacher ratio(headcount basis) of Low income in 1977 and the Pupil-teacher ratio(headcount basis) of France in 1999?
Your answer should be compact. 12.76. What is the difference between the Pupil-teacher ratio(headcount basis) in Low income in 1977 and the Pupil-teacher ratio(headcount basis) in Macao in 1999?
Provide a short and direct response. 1.85. What is the difference between the Pupil-teacher ratio(headcount basis) of Low income in 1977 and the Pupil-teacher ratio(headcount basis) of Panama in 1999?
Ensure brevity in your answer.  8.79. What is the difference between the Pupil-teacher ratio(headcount basis) in France in 1977 and the Pupil-teacher ratio(headcount basis) in Macao in 1999?
Ensure brevity in your answer.  -8.78. What is the difference between the Pupil-teacher ratio(headcount basis) in France in 1977 and the Pupil-teacher ratio(headcount basis) in Panama in 1999?
Your answer should be compact. -1.84. What is the difference between the Pupil-teacher ratio(headcount basis) in Macao in 1977 and the Pupil-teacher ratio(headcount basis) in Panama in 1999?
Provide a short and direct response. 3.41. What is the difference between the Pupil-teacher ratio(headcount basis) of Low income in 1977 and the Pupil-teacher ratio(headcount basis) of France in 2000?
Offer a terse response. 12.99. What is the difference between the Pupil-teacher ratio(headcount basis) of Low income in 1977 and the Pupil-teacher ratio(headcount basis) of Macao in 2000?
Your answer should be very brief. 0.91. What is the difference between the Pupil-teacher ratio(headcount basis) of Low income in 1977 and the Pupil-teacher ratio(headcount basis) of Panama in 2000?
Ensure brevity in your answer.  8.53. What is the difference between the Pupil-teacher ratio(headcount basis) in France in 1977 and the Pupil-teacher ratio(headcount basis) in Macao in 2000?
Ensure brevity in your answer.  -9.72. What is the difference between the Pupil-teacher ratio(headcount basis) of France in 1977 and the Pupil-teacher ratio(headcount basis) of Panama in 2000?
Ensure brevity in your answer.  -2.1. What is the difference between the Pupil-teacher ratio(headcount basis) of Macao in 1977 and the Pupil-teacher ratio(headcount basis) of Panama in 2000?
Provide a succinct answer. 3.15. What is the difference between the Pupil-teacher ratio(headcount basis) of Low income in 1977 and the Pupil-teacher ratio(headcount basis) of France in 2001?
Offer a terse response. 13.18. What is the difference between the Pupil-teacher ratio(headcount basis) in Low income in 1977 and the Pupil-teacher ratio(headcount basis) in Macao in 2001?
Ensure brevity in your answer.  0.76. What is the difference between the Pupil-teacher ratio(headcount basis) in Low income in 1977 and the Pupil-teacher ratio(headcount basis) in Panama in 2001?
Your answer should be very brief. 8.71. What is the difference between the Pupil-teacher ratio(headcount basis) of France in 1977 and the Pupil-teacher ratio(headcount basis) of Macao in 2001?
Offer a terse response. -9.86. What is the difference between the Pupil-teacher ratio(headcount basis) in France in 1977 and the Pupil-teacher ratio(headcount basis) in Panama in 2001?
Make the answer very short. -1.92. What is the difference between the Pupil-teacher ratio(headcount basis) in Macao in 1977 and the Pupil-teacher ratio(headcount basis) in Panama in 2001?
Offer a very short reply. 3.33. What is the difference between the Pupil-teacher ratio(headcount basis) of Low income in 1978 and the Pupil-teacher ratio(headcount basis) of France in 1979?
Provide a short and direct response. 11.18. What is the difference between the Pupil-teacher ratio(headcount basis) of Low income in 1978 and the Pupil-teacher ratio(headcount basis) of Macao in 1979?
Provide a short and direct response. 3.72. What is the difference between the Pupil-teacher ratio(headcount basis) in Low income in 1978 and the Pupil-teacher ratio(headcount basis) in Panama in 1979?
Provide a succinct answer. -2.43. What is the difference between the Pupil-teacher ratio(headcount basis) of France in 1978 and the Pupil-teacher ratio(headcount basis) of Macao in 1979?
Provide a succinct answer. -7.3. What is the difference between the Pupil-teacher ratio(headcount basis) in France in 1978 and the Pupil-teacher ratio(headcount basis) in Panama in 1979?
Provide a succinct answer. -13.46. What is the difference between the Pupil-teacher ratio(headcount basis) in Macao in 1978 and the Pupil-teacher ratio(headcount basis) in Panama in 1979?
Provide a short and direct response. -12.33. What is the difference between the Pupil-teacher ratio(headcount basis) of Low income in 1978 and the Pupil-teacher ratio(headcount basis) of France in 1999?
Your answer should be compact. 13.02. What is the difference between the Pupil-teacher ratio(headcount basis) of Low income in 1978 and the Pupil-teacher ratio(headcount basis) of Macao in 1999?
Your answer should be compact. 2.11. What is the difference between the Pupil-teacher ratio(headcount basis) in Low income in 1978 and the Pupil-teacher ratio(headcount basis) in Panama in 1999?
Provide a succinct answer. 9.05. What is the difference between the Pupil-teacher ratio(headcount basis) in France in 1978 and the Pupil-teacher ratio(headcount basis) in Macao in 1999?
Offer a very short reply. -8.92. What is the difference between the Pupil-teacher ratio(headcount basis) of France in 1978 and the Pupil-teacher ratio(headcount basis) of Panama in 1999?
Make the answer very short. -1.98. What is the difference between the Pupil-teacher ratio(headcount basis) in Macao in 1978 and the Pupil-teacher ratio(headcount basis) in Panama in 1999?
Make the answer very short. -0.85. What is the difference between the Pupil-teacher ratio(headcount basis) in Low income in 1978 and the Pupil-teacher ratio(headcount basis) in France in 2000?
Give a very brief answer. 13.24. What is the difference between the Pupil-teacher ratio(headcount basis) of Low income in 1978 and the Pupil-teacher ratio(headcount basis) of Macao in 2000?
Provide a short and direct response. 1.16. What is the difference between the Pupil-teacher ratio(headcount basis) of Low income in 1978 and the Pupil-teacher ratio(headcount basis) of Panama in 2000?
Your response must be concise. 8.79. What is the difference between the Pupil-teacher ratio(headcount basis) of France in 1978 and the Pupil-teacher ratio(headcount basis) of Macao in 2000?
Make the answer very short. -9.86. What is the difference between the Pupil-teacher ratio(headcount basis) of France in 1978 and the Pupil-teacher ratio(headcount basis) of Panama in 2000?
Give a very brief answer. -2.24. What is the difference between the Pupil-teacher ratio(headcount basis) of Macao in 1978 and the Pupil-teacher ratio(headcount basis) of Panama in 2000?
Give a very brief answer. -1.11. What is the difference between the Pupil-teacher ratio(headcount basis) in Low income in 1978 and the Pupil-teacher ratio(headcount basis) in France in 2001?
Your response must be concise. 13.44. What is the difference between the Pupil-teacher ratio(headcount basis) in Low income in 1978 and the Pupil-teacher ratio(headcount basis) in Macao in 2001?
Ensure brevity in your answer.  1.02. What is the difference between the Pupil-teacher ratio(headcount basis) in Low income in 1978 and the Pupil-teacher ratio(headcount basis) in Panama in 2001?
Your answer should be compact. 8.96. What is the difference between the Pupil-teacher ratio(headcount basis) of France in 1978 and the Pupil-teacher ratio(headcount basis) of Macao in 2001?
Your response must be concise. -10. What is the difference between the Pupil-teacher ratio(headcount basis) of France in 1978 and the Pupil-teacher ratio(headcount basis) of Panama in 2001?
Offer a very short reply. -2.06. What is the difference between the Pupil-teacher ratio(headcount basis) of Macao in 1978 and the Pupil-teacher ratio(headcount basis) of Panama in 2001?
Your answer should be compact. -0.93. What is the difference between the Pupil-teacher ratio(headcount basis) of Low income in 1979 and the Pupil-teacher ratio(headcount basis) of France in 1999?
Your answer should be very brief. 13.38. What is the difference between the Pupil-teacher ratio(headcount basis) of Low income in 1979 and the Pupil-teacher ratio(headcount basis) of Macao in 1999?
Keep it short and to the point. 2.46. What is the difference between the Pupil-teacher ratio(headcount basis) in Low income in 1979 and the Pupil-teacher ratio(headcount basis) in Panama in 1999?
Provide a short and direct response. 9.4. What is the difference between the Pupil-teacher ratio(headcount basis) of France in 1979 and the Pupil-teacher ratio(headcount basis) of Macao in 1999?
Give a very brief answer. -9.07. What is the difference between the Pupil-teacher ratio(headcount basis) in France in 1979 and the Pupil-teacher ratio(headcount basis) in Panama in 1999?
Keep it short and to the point. -2.13. What is the difference between the Pupil-teacher ratio(headcount basis) of Macao in 1979 and the Pupil-teacher ratio(headcount basis) of Panama in 1999?
Make the answer very short. 5.33. What is the difference between the Pupil-teacher ratio(headcount basis) in Low income in 1979 and the Pupil-teacher ratio(headcount basis) in France in 2000?
Your answer should be very brief. 13.6. What is the difference between the Pupil-teacher ratio(headcount basis) in Low income in 1979 and the Pupil-teacher ratio(headcount basis) in Macao in 2000?
Provide a short and direct response. 1.52. What is the difference between the Pupil-teacher ratio(headcount basis) in Low income in 1979 and the Pupil-teacher ratio(headcount basis) in Panama in 2000?
Your answer should be compact. 9.15. What is the difference between the Pupil-teacher ratio(headcount basis) of France in 1979 and the Pupil-teacher ratio(headcount basis) of Macao in 2000?
Provide a succinct answer. -10.02. What is the difference between the Pupil-teacher ratio(headcount basis) of France in 1979 and the Pupil-teacher ratio(headcount basis) of Panama in 2000?
Offer a very short reply. -2.39. What is the difference between the Pupil-teacher ratio(headcount basis) in Macao in 1979 and the Pupil-teacher ratio(headcount basis) in Panama in 2000?
Your response must be concise. 5.07. What is the difference between the Pupil-teacher ratio(headcount basis) in Low income in 1979 and the Pupil-teacher ratio(headcount basis) in France in 2001?
Give a very brief answer. 13.8. What is the difference between the Pupil-teacher ratio(headcount basis) of Low income in 1979 and the Pupil-teacher ratio(headcount basis) of Macao in 2001?
Your response must be concise. 1.38. What is the difference between the Pupil-teacher ratio(headcount basis) in Low income in 1979 and the Pupil-teacher ratio(headcount basis) in Panama in 2001?
Your response must be concise. 9.32. What is the difference between the Pupil-teacher ratio(headcount basis) of France in 1979 and the Pupil-teacher ratio(headcount basis) of Macao in 2001?
Offer a terse response. -10.16. What is the difference between the Pupil-teacher ratio(headcount basis) of France in 1979 and the Pupil-teacher ratio(headcount basis) of Panama in 2001?
Offer a terse response. -2.21. What is the difference between the Pupil-teacher ratio(headcount basis) of Macao in 1979 and the Pupil-teacher ratio(headcount basis) of Panama in 2001?
Provide a short and direct response. 5.24. What is the difference between the Pupil-teacher ratio(headcount basis) of Low income in 1999 and the Pupil-teacher ratio(headcount basis) of France in 2000?
Your answer should be compact. 12.65. What is the difference between the Pupil-teacher ratio(headcount basis) in Low income in 1999 and the Pupil-teacher ratio(headcount basis) in Macao in 2000?
Your answer should be compact. 0.57. What is the difference between the Pupil-teacher ratio(headcount basis) of Low income in 1999 and the Pupil-teacher ratio(headcount basis) of Panama in 2000?
Make the answer very short. 8.19. What is the difference between the Pupil-teacher ratio(headcount basis) in France in 1999 and the Pupil-teacher ratio(headcount basis) in Macao in 2000?
Offer a terse response. -11.86. What is the difference between the Pupil-teacher ratio(headcount basis) of France in 1999 and the Pupil-teacher ratio(headcount basis) of Panama in 2000?
Give a very brief answer. -4.23. What is the difference between the Pupil-teacher ratio(headcount basis) in Macao in 1999 and the Pupil-teacher ratio(headcount basis) in Panama in 2000?
Provide a succinct answer. 6.68. What is the difference between the Pupil-teacher ratio(headcount basis) in Low income in 1999 and the Pupil-teacher ratio(headcount basis) in France in 2001?
Give a very brief answer. 12.84. What is the difference between the Pupil-teacher ratio(headcount basis) of Low income in 1999 and the Pupil-teacher ratio(headcount basis) of Macao in 2001?
Keep it short and to the point. 0.43. What is the difference between the Pupil-teacher ratio(headcount basis) of Low income in 1999 and the Pupil-teacher ratio(headcount basis) of Panama in 2001?
Offer a very short reply. 8.37. What is the difference between the Pupil-teacher ratio(headcount basis) in France in 1999 and the Pupil-teacher ratio(headcount basis) in Macao in 2001?
Your answer should be very brief. -12. What is the difference between the Pupil-teacher ratio(headcount basis) of France in 1999 and the Pupil-teacher ratio(headcount basis) of Panama in 2001?
Give a very brief answer. -4.05. What is the difference between the Pupil-teacher ratio(headcount basis) of Macao in 1999 and the Pupil-teacher ratio(headcount basis) of Panama in 2001?
Make the answer very short. 6.86. What is the difference between the Pupil-teacher ratio(headcount basis) in Low income in 2000 and the Pupil-teacher ratio(headcount basis) in France in 2001?
Make the answer very short. 12.51. What is the difference between the Pupil-teacher ratio(headcount basis) in Low income in 2000 and the Pupil-teacher ratio(headcount basis) in Macao in 2001?
Your answer should be very brief. 0.09. What is the difference between the Pupil-teacher ratio(headcount basis) in Low income in 2000 and the Pupil-teacher ratio(headcount basis) in Panama in 2001?
Provide a succinct answer. 8.04. What is the difference between the Pupil-teacher ratio(headcount basis) in France in 2000 and the Pupil-teacher ratio(headcount basis) in Macao in 2001?
Keep it short and to the point. -12.23. What is the difference between the Pupil-teacher ratio(headcount basis) in France in 2000 and the Pupil-teacher ratio(headcount basis) in Panama in 2001?
Your answer should be compact. -4.28. What is the difference between the Pupil-teacher ratio(headcount basis) of Macao in 2000 and the Pupil-teacher ratio(headcount basis) of Panama in 2001?
Your answer should be very brief. 7.8. What is the average Pupil-teacher ratio(headcount basis) in Low income per year?
Offer a very short reply. 24.31. What is the average Pupil-teacher ratio(headcount basis) of France per year?
Offer a very short reply. 13.6. What is the average Pupil-teacher ratio(headcount basis) of Macao per year?
Keep it short and to the point. 19.36. What is the average Pupil-teacher ratio(headcount basis) of Panama per year?
Offer a very short reply. 21.1. In the year 1971, what is the difference between the Pupil-teacher ratio(headcount basis) in Low income and Pupil-teacher ratio(headcount basis) in France?
Offer a very short reply. 7.11. In the year 1971, what is the difference between the Pupil-teacher ratio(headcount basis) of Low income and Pupil-teacher ratio(headcount basis) of Macao?
Provide a short and direct response. 9.11. In the year 1971, what is the difference between the Pupil-teacher ratio(headcount basis) of Low income and Pupil-teacher ratio(headcount basis) of Panama?
Provide a short and direct response. 3.45. In the year 1971, what is the difference between the Pupil-teacher ratio(headcount basis) in France and Pupil-teacher ratio(headcount basis) in Macao?
Your answer should be very brief. 2. In the year 1971, what is the difference between the Pupil-teacher ratio(headcount basis) of France and Pupil-teacher ratio(headcount basis) of Panama?
Make the answer very short. -3.66. In the year 1971, what is the difference between the Pupil-teacher ratio(headcount basis) in Macao and Pupil-teacher ratio(headcount basis) in Panama?
Your answer should be compact. -5.66. In the year 1972, what is the difference between the Pupil-teacher ratio(headcount basis) in Low income and Pupil-teacher ratio(headcount basis) in France?
Make the answer very short. 7.7. In the year 1972, what is the difference between the Pupil-teacher ratio(headcount basis) of Low income and Pupil-teacher ratio(headcount basis) of Macao?
Give a very brief answer. 8.82. In the year 1972, what is the difference between the Pupil-teacher ratio(headcount basis) of Low income and Pupil-teacher ratio(headcount basis) of Panama?
Ensure brevity in your answer.  3.58. In the year 1972, what is the difference between the Pupil-teacher ratio(headcount basis) in France and Pupil-teacher ratio(headcount basis) in Macao?
Keep it short and to the point. 1.12. In the year 1972, what is the difference between the Pupil-teacher ratio(headcount basis) in France and Pupil-teacher ratio(headcount basis) in Panama?
Offer a very short reply. -4.12. In the year 1972, what is the difference between the Pupil-teacher ratio(headcount basis) of Macao and Pupil-teacher ratio(headcount basis) of Panama?
Give a very brief answer. -5.23. In the year 1977, what is the difference between the Pupil-teacher ratio(headcount basis) in Low income and Pupil-teacher ratio(headcount basis) in France?
Give a very brief answer. 10.63. In the year 1977, what is the difference between the Pupil-teacher ratio(headcount basis) in Low income and Pupil-teacher ratio(headcount basis) in Macao?
Keep it short and to the point. 5.38. In the year 1977, what is the difference between the Pupil-teacher ratio(headcount basis) of Low income and Pupil-teacher ratio(headcount basis) of Panama?
Your answer should be compact. -1.47. In the year 1977, what is the difference between the Pupil-teacher ratio(headcount basis) in France and Pupil-teacher ratio(headcount basis) in Macao?
Provide a succinct answer. -5.25. In the year 1977, what is the difference between the Pupil-teacher ratio(headcount basis) of France and Pupil-teacher ratio(headcount basis) of Panama?
Your answer should be compact. -12.09. In the year 1977, what is the difference between the Pupil-teacher ratio(headcount basis) of Macao and Pupil-teacher ratio(headcount basis) of Panama?
Offer a very short reply. -6.84. In the year 1978, what is the difference between the Pupil-teacher ratio(headcount basis) of Low income and Pupil-teacher ratio(headcount basis) of France?
Make the answer very short. 11.02. In the year 1978, what is the difference between the Pupil-teacher ratio(headcount basis) of Low income and Pupil-teacher ratio(headcount basis) of Macao?
Keep it short and to the point. 9.89. In the year 1978, what is the difference between the Pupil-teacher ratio(headcount basis) in Low income and Pupil-teacher ratio(headcount basis) in Panama?
Your answer should be very brief. -2.59. In the year 1978, what is the difference between the Pupil-teacher ratio(headcount basis) in France and Pupil-teacher ratio(headcount basis) in Macao?
Keep it short and to the point. -1.13. In the year 1978, what is the difference between the Pupil-teacher ratio(headcount basis) in France and Pupil-teacher ratio(headcount basis) in Panama?
Offer a terse response. -13.61. In the year 1978, what is the difference between the Pupil-teacher ratio(headcount basis) in Macao and Pupil-teacher ratio(headcount basis) in Panama?
Ensure brevity in your answer.  -12.48. In the year 1979, what is the difference between the Pupil-teacher ratio(headcount basis) of Low income and Pupil-teacher ratio(headcount basis) of France?
Your response must be concise. 11.54. In the year 1979, what is the difference between the Pupil-teacher ratio(headcount basis) of Low income and Pupil-teacher ratio(headcount basis) of Macao?
Give a very brief answer. 4.08. In the year 1979, what is the difference between the Pupil-teacher ratio(headcount basis) of Low income and Pupil-teacher ratio(headcount basis) of Panama?
Provide a succinct answer. -2.08. In the year 1979, what is the difference between the Pupil-teacher ratio(headcount basis) in France and Pupil-teacher ratio(headcount basis) in Macao?
Offer a very short reply. -7.46. In the year 1979, what is the difference between the Pupil-teacher ratio(headcount basis) of France and Pupil-teacher ratio(headcount basis) of Panama?
Offer a very short reply. -13.61. In the year 1979, what is the difference between the Pupil-teacher ratio(headcount basis) of Macao and Pupil-teacher ratio(headcount basis) of Panama?
Provide a succinct answer. -6.15. In the year 1999, what is the difference between the Pupil-teacher ratio(headcount basis) in Low income and Pupil-teacher ratio(headcount basis) in France?
Your answer should be very brief. 12.42. In the year 1999, what is the difference between the Pupil-teacher ratio(headcount basis) in Low income and Pupil-teacher ratio(headcount basis) in Macao?
Give a very brief answer. 1.51. In the year 1999, what is the difference between the Pupil-teacher ratio(headcount basis) in Low income and Pupil-teacher ratio(headcount basis) in Panama?
Give a very brief answer. 8.45. In the year 1999, what is the difference between the Pupil-teacher ratio(headcount basis) of France and Pupil-teacher ratio(headcount basis) of Macao?
Keep it short and to the point. -10.91. In the year 1999, what is the difference between the Pupil-teacher ratio(headcount basis) of France and Pupil-teacher ratio(headcount basis) of Panama?
Your answer should be compact. -3.97. In the year 1999, what is the difference between the Pupil-teacher ratio(headcount basis) in Macao and Pupil-teacher ratio(headcount basis) in Panama?
Your response must be concise. 6.94. In the year 2000, what is the difference between the Pupil-teacher ratio(headcount basis) of Low income and Pupil-teacher ratio(headcount basis) of France?
Your answer should be compact. 12.32. In the year 2000, what is the difference between the Pupil-teacher ratio(headcount basis) of Low income and Pupil-teacher ratio(headcount basis) of Macao?
Your answer should be very brief. 0.24. In the year 2000, what is the difference between the Pupil-teacher ratio(headcount basis) in Low income and Pupil-teacher ratio(headcount basis) in Panama?
Your answer should be very brief. 7.86. In the year 2000, what is the difference between the Pupil-teacher ratio(headcount basis) of France and Pupil-teacher ratio(headcount basis) of Macao?
Make the answer very short. -12.08. In the year 2000, what is the difference between the Pupil-teacher ratio(headcount basis) of France and Pupil-teacher ratio(headcount basis) of Panama?
Provide a succinct answer. -4.46. In the year 2000, what is the difference between the Pupil-teacher ratio(headcount basis) in Macao and Pupil-teacher ratio(headcount basis) in Panama?
Ensure brevity in your answer.  7.62. In the year 2001, what is the difference between the Pupil-teacher ratio(headcount basis) of Low income and Pupil-teacher ratio(headcount basis) of France?
Ensure brevity in your answer.  12.99. In the year 2001, what is the difference between the Pupil-teacher ratio(headcount basis) of Low income and Pupil-teacher ratio(headcount basis) of Macao?
Your answer should be compact. 0.57. In the year 2001, what is the difference between the Pupil-teacher ratio(headcount basis) in Low income and Pupil-teacher ratio(headcount basis) in Panama?
Give a very brief answer. 8.52. In the year 2001, what is the difference between the Pupil-teacher ratio(headcount basis) in France and Pupil-teacher ratio(headcount basis) in Macao?
Your answer should be very brief. -12.42. In the year 2001, what is the difference between the Pupil-teacher ratio(headcount basis) of France and Pupil-teacher ratio(headcount basis) of Panama?
Ensure brevity in your answer.  -4.47. In the year 2001, what is the difference between the Pupil-teacher ratio(headcount basis) of Macao and Pupil-teacher ratio(headcount basis) of Panama?
Your answer should be very brief. 7.95. What is the ratio of the Pupil-teacher ratio(headcount basis) in Low income in 1971 to that in 1972?
Provide a succinct answer. 0.99. What is the ratio of the Pupil-teacher ratio(headcount basis) in France in 1971 to that in 1972?
Your answer should be compact. 1.02. What is the ratio of the Pupil-teacher ratio(headcount basis) of Macao in 1971 to that in 1972?
Keep it short and to the point. 0.96. What is the ratio of the Pupil-teacher ratio(headcount basis) in Low income in 1971 to that in 1977?
Offer a terse response. 0.92. What is the ratio of the Pupil-teacher ratio(headcount basis) in France in 1971 to that in 1977?
Make the answer very short. 1.12. What is the ratio of the Pupil-teacher ratio(headcount basis) in Macao in 1971 to that in 1977?
Make the answer very short. 0.71. What is the ratio of the Pupil-teacher ratio(headcount basis) of Panama in 1971 to that in 1977?
Keep it short and to the point. 0.74. What is the ratio of the Pupil-teacher ratio(headcount basis) in Low income in 1971 to that in 1978?
Provide a succinct answer. 0.91. What is the ratio of the Pupil-teacher ratio(headcount basis) of France in 1971 to that in 1978?
Keep it short and to the point. 1.13. What is the ratio of the Pupil-teacher ratio(headcount basis) of Macao in 1971 to that in 1978?
Your answer should be compact. 0.91. What is the ratio of the Pupil-teacher ratio(headcount basis) of Panama in 1971 to that in 1978?
Provide a short and direct response. 0.7. What is the ratio of the Pupil-teacher ratio(headcount basis) of Low income in 1971 to that in 1979?
Keep it short and to the point. 0.9. What is the ratio of the Pupil-teacher ratio(headcount basis) in France in 1971 to that in 1979?
Your answer should be compact. 1.14. What is the ratio of the Pupil-teacher ratio(headcount basis) in Macao in 1971 to that in 1979?
Ensure brevity in your answer.  0.65. What is the ratio of the Pupil-teacher ratio(headcount basis) of Panama in 1971 to that in 1979?
Give a very brief answer. 0.71. What is the ratio of the Pupil-teacher ratio(headcount basis) of Low income in 1971 to that in 1999?
Your answer should be compact. 0.94. What is the ratio of the Pupil-teacher ratio(headcount basis) in France in 1971 to that in 1999?
Give a very brief answer. 1.31. What is the ratio of the Pupil-teacher ratio(headcount basis) in Macao in 1971 to that in 1999?
Give a very brief answer. 0.6. What is the ratio of the Pupil-teacher ratio(headcount basis) of Panama in 1971 to that in 1999?
Make the answer very short. 1.22. What is the ratio of the Pupil-teacher ratio(headcount basis) in Low income in 1971 to that in 2000?
Keep it short and to the point. 0.95. What is the ratio of the Pupil-teacher ratio(headcount basis) in France in 1971 to that in 2000?
Give a very brief answer. 1.34. What is the ratio of the Pupil-teacher ratio(headcount basis) of Macao in 1971 to that in 2000?
Ensure brevity in your answer.  0.58. What is the ratio of the Pupil-teacher ratio(headcount basis) in Panama in 1971 to that in 2000?
Provide a short and direct response. 1.2. What is the ratio of the Pupil-teacher ratio(headcount basis) in Low income in 1971 to that in 2001?
Offer a very short reply. 0.93. What is the ratio of the Pupil-teacher ratio(headcount basis) in France in 1971 to that in 2001?
Your response must be concise. 1.36. What is the ratio of the Pupil-teacher ratio(headcount basis) of Macao in 1971 to that in 2001?
Ensure brevity in your answer.  0.57. What is the ratio of the Pupil-teacher ratio(headcount basis) of Panama in 1971 to that in 2001?
Provide a succinct answer. 1.21. What is the ratio of the Pupil-teacher ratio(headcount basis) in Low income in 1972 to that in 1977?
Your answer should be very brief. 0.94. What is the ratio of the Pupil-teacher ratio(headcount basis) in France in 1972 to that in 1977?
Provide a short and direct response. 1.09. What is the ratio of the Pupil-teacher ratio(headcount basis) in Macao in 1972 to that in 1977?
Give a very brief answer. 0.74. What is the ratio of the Pupil-teacher ratio(headcount basis) of Panama in 1972 to that in 1977?
Give a very brief answer. 0.75. What is the ratio of the Pupil-teacher ratio(headcount basis) in Low income in 1972 to that in 1978?
Make the answer very short. 0.93. What is the ratio of the Pupil-teacher ratio(headcount basis) in France in 1972 to that in 1978?
Keep it short and to the point. 1.11. What is the ratio of the Pupil-teacher ratio(headcount basis) in Macao in 1972 to that in 1978?
Ensure brevity in your answer.  0.95. What is the ratio of the Pupil-teacher ratio(headcount basis) in Panama in 1972 to that in 1978?
Provide a succinct answer. 0.71. What is the ratio of the Pupil-teacher ratio(headcount basis) in Low income in 1972 to that in 1979?
Your answer should be very brief. 0.91. What is the ratio of the Pupil-teacher ratio(headcount basis) in France in 1972 to that in 1979?
Keep it short and to the point. 1.12. What is the ratio of the Pupil-teacher ratio(headcount basis) in Macao in 1972 to that in 1979?
Provide a succinct answer. 0.67. What is the ratio of the Pupil-teacher ratio(headcount basis) in Panama in 1972 to that in 1979?
Your answer should be very brief. 0.71. What is the ratio of the Pupil-teacher ratio(headcount basis) of Low income in 1972 to that in 1999?
Your answer should be compact. 0.95. What is the ratio of the Pupil-teacher ratio(headcount basis) in France in 1972 to that in 1999?
Your response must be concise. 1.29. What is the ratio of the Pupil-teacher ratio(headcount basis) of Macao in 1972 to that in 1999?
Make the answer very short. 0.63. What is the ratio of the Pupil-teacher ratio(headcount basis) of Panama in 1972 to that in 1999?
Offer a very short reply. 1.23. What is the ratio of the Pupil-teacher ratio(headcount basis) of Low income in 1972 to that in 2000?
Ensure brevity in your answer.  0.96. What is the ratio of the Pupil-teacher ratio(headcount basis) in France in 1972 to that in 2000?
Offer a terse response. 1.31. What is the ratio of the Pupil-teacher ratio(headcount basis) in Macao in 1972 to that in 2000?
Offer a very short reply. 0.6. What is the ratio of the Pupil-teacher ratio(headcount basis) of Panama in 1972 to that in 2000?
Keep it short and to the point. 1.21. What is the ratio of the Pupil-teacher ratio(headcount basis) in Low income in 1972 to that in 2001?
Offer a very short reply. 0.94. What is the ratio of the Pupil-teacher ratio(headcount basis) of France in 1972 to that in 2001?
Provide a short and direct response. 1.34. What is the ratio of the Pupil-teacher ratio(headcount basis) of Macao in 1972 to that in 2001?
Ensure brevity in your answer.  0.6. What is the ratio of the Pupil-teacher ratio(headcount basis) in Panama in 1972 to that in 2001?
Keep it short and to the point. 1.22. What is the ratio of the Pupil-teacher ratio(headcount basis) in France in 1977 to that in 1978?
Provide a succinct answer. 1.01. What is the ratio of the Pupil-teacher ratio(headcount basis) in Macao in 1977 to that in 1978?
Your answer should be compact. 1.28. What is the ratio of the Pupil-teacher ratio(headcount basis) of Panama in 1977 to that in 1978?
Provide a short and direct response. 0.95. What is the ratio of the Pupil-teacher ratio(headcount basis) in Low income in 1977 to that in 1979?
Make the answer very short. 0.98. What is the ratio of the Pupil-teacher ratio(headcount basis) of France in 1977 to that in 1979?
Ensure brevity in your answer.  1.02. What is the ratio of the Pupil-teacher ratio(headcount basis) of Macao in 1977 to that in 1979?
Keep it short and to the point. 0.91. What is the ratio of the Pupil-teacher ratio(headcount basis) of Panama in 1977 to that in 1979?
Ensure brevity in your answer.  0.96. What is the ratio of the Pupil-teacher ratio(headcount basis) of Low income in 1977 to that in 1999?
Keep it short and to the point. 1.01. What is the ratio of the Pupil-teacher ratio(headcount basis) in France in 1977 to that in 1999?
Your answer should be compact. 1.18. What is the ratio of the Pupil-teacher ratio(headcount basis) of Macao in 1977 to that in 1999?
Keep it short and to the point. 0.85. What is the ratio of the Pupil-teacher ratio(headcount basis) of Panama in 1977 to that in 1999?
Make the answer very short. 1.64. What is the ratio of the Pupil-teacher ratio(headcount basis) of Low income in 1977 to that in 2000?
Offer a very short reply. 1.03. What is the ratio of the Pupil-teacher ratio(headcount basis) of France in 1977 to that in 2000?
Offer a terse response. 1.2. What is the ratio of the Pupil-teacher ratio(headcount basis) of Macao in 1977 to that in 2000?
Offer a very short reply. 0.81. What is the ratio of the Pupil-teacher ratio(headcount basis) in Panama in 1977 to that in 2000?
Your answer should be very brief. 1.61. What is the ratio of the Pupil-teacher ratio(headcount basis) in France in 1977 to that in 2001?
Offer a very short reply. 1.22. What is the ratio of the Pupil-teacher ratio(headcount basis) in Macao in 1977 to that in 2001?
Provide a succinct answer. 0.81. What is the ratio of the Pupil-teacher ratio(headcount basis) in Panama in 1977 to that in 2001?
Provide a succinct answer. 1.63. What is the ratio of the Pupil-teacher ratio(headcount basis) in Low income in 1978 to that in 1979?
Your response must be concise. 0.99. What is the ratio of the Pupil-teacher ratio(headcount basis) of France in 1978 to that in 1979?
Your response must be concise. 1.01. What is the ratio of the Pupil-teacher ratio(headcount basis) in Macao in 1978 to that in 1979?
Offer a very short reply. 0.71. What is the ratio of the Pupil-teacher ratio(headcount basis) of Low income in 1978 to that in 1999?
Your answer should be compact. 1.02. What is the ratio of the Pupil-teacher ratio(headcount basis) of France in 1978 to that in 1999?
Offer a very short reply. 1.17. What is the ratio of the Pupil-teacher ratio(headcount basis) in Macao in 1978 to that in 1999?
Give a very brief answer. 0.66. What is the ratio of the Pupil-teacher ratio(headcount basis) in Panama in 1978 to that in 1999?
Your answer should be compact. 1.73. What is the ratio of the Pupil-teacher ratio(headcount basis) in Low income in 1978 to that in 2000?
Provide a succinct answer. 1.04. What is the ratio of the Pupil-teacher ratio(headcount basis) of France in 1978 to that in 2000?
Offer a very short reply. 1.19. What is the ratio of the Pupil-teacher ratio(headcount basis) in Macao in 1978 to that in 2000?
Keep it short and to the point. 0.63. What is the ratio of the Pupil-teacher ratio(headcount basis) of Panama in 1978 to that in 2000?
Offer a terse response. 1.7. What is the ratio of the Pupil-teacher ratio(headcount basis) in Low income in 1978 to that in 2001?
Make the answer very short. 1.02. What is the ratio of the Pupil-teacher ratio(headcount basis) in France in 1978 to that in 2001?
Offer a very short reply. 1.21. What is the ratio of the Pupil-teacher ratio(headcount basis) in Macao in 1978 to that in 2001?
Offer a terse response. 0.63. What is the ratio of the Pupil-teacher ratio(headcount basis) of Panama in 1978 to that in 2001?
Your answer should be compact. 1.72. What is the ratio of the Pupil-teacher ratio(headcount basis) of Low income in 1979 to that in 1999?
Make the answer very short. 1.04. What is the ratio of the Pupil-teacher ratio(headcount basis) in France in 1979 to that in 1999?
Offer a very short reply. 1.15. What is the ratio of the Pupil-teacher ratio(headcount basis) in Macao in 1979 to that in 1999?
Provide a short and direct response. 0.93. What is the ratio of the Pupil-teacher ratio(headcount basis) in Panama in 1979 to that in 1999?
Keep it short and to the point. 1.72. What is the ratio of the Pupil-teacher ratio(headcount basis) in Low income in 1979 to that in 2000?
Your answer should be very brief. 1.05. What is the ratio of the Pupil-teacher ratio(headcount basis) in France in 1979 to that in 2000?
Make the answer very short. 1.18. What is the ratio of the Pupil-teacher ratio(headcount basis) of Macao in 1979 to that in 2000?
Your answer should be compact. 0.89. What is the ratio of the Pupil-teacher ratio(headcount basis) of Panama in 1979 to that in 2000?
Keep it short and to the point. 1.69. What is the ratio of the Pupil-teacher ratio(headcount basis) of Low income in 1979 to that in 2001?
Keep it short and to the point. 1.03. What is the ratio of the Pupil-teacher ratio(headcount basis) in France in 1979 to that in 2001?
Ensure brevity in your answer.  1.19. What is the ratio of the Pupil-teacher ratio(headcount basis) of Macao in 1979 to that in 2001?
Provide a short and direct response. 0.89. What is the ratio of the Pupil-teacher ratio(headcount basis) of Panama in 1979 to that in 2001?
Keep it short and to the point. 1.71. What is the ratio of the Pupil-teacher ratio(headcount basis) of Low income in 1999 to that in 2000?
Ensure brevity in your answer.  1.01. What is the ratio of the Pupil-teacher ratio(headcount basis) in France in 1999 to that in 2000?
Offer a terse response. 1.02. What is the ratio of the Pupil-teacher ratio(headcount basis) in Macao in 1999 to that in 2000?
Your response must be concise. 0.96. What is the ratio of the Pupil-teacher ratio(headcount basis) in Panama in 1999 to that in 2000?
Your answer should be compact. 0.98. What is the ratio of the Pupil-teacher ratio(headcount basis) of France in 1999 to that in 2001?
Your answer should be very brief. 1.04. What is the ratio of the Pupil-teacher ratio(headcount basis) in Macao in 1999 to that in 2001?
Your answer should be compact. 0.95. What is the ratio of the Pupil-teacher ratio(headcount basis) of Panama in 1999 to that in 2001?
Your answer should be very brief. 0.99. What is the ratio of the Pupil-teacher ratio(headcount basis) of Low income in 2000 to that in 2001?
Provide a short and direct response. 0.98. What is the ratio of the Pupil-teacher ratio(headcount basis) of France in 2000 to that in 2001?
Offer a very short reply. 1.02. What is the ratio of the Pupil-teacher ratio(headcount basis) of Macao in 2000 to that in 2001?
Ensure brevity in your answer.  0.99. What is the ratio of the Pupil-teacher ratio(headcount basis) in Panama in 2000 to that in 2001?
Your answer should be very brief. 1.01. What is the difference between the highest and the second highest Pupil-teacher ratio(headcount basis) of Low income?
Your response must be concise. 0.36. What is the difference between the highest and the second highest Pupil-teacher ratio(headcount basis) of France?
Keep it short and to the point. 0.3. What is the difference between the highest and the second highest Pupil-teacher ratio(headcount basis) of Macao?
Make the answer very short. 0.14. What is the difference between the highest and the second highest Pupil-teacher ratio(headcount basis) in Panama?
Your answer should be compact. 0.16. What is the difference between the highest and the lowest Pupil-teacher ratio(headcount basis) in Low income?
Offer a terse response. 2.49. What is the difference between the highest and the lowest Pupil-teacher ratio(headcount basis) in France?
Your answer should be compact. 4.2. What is the difference between the highest and the lowest Pupil-teacher ratio(headcount basis) in Macao?
Offer a very short reply. 10.22. What is the difference between the highest and the lowest Pupil-teacher ratio(headcount basis) in Panama?
Ensure brevity in your answer.  11.64. 